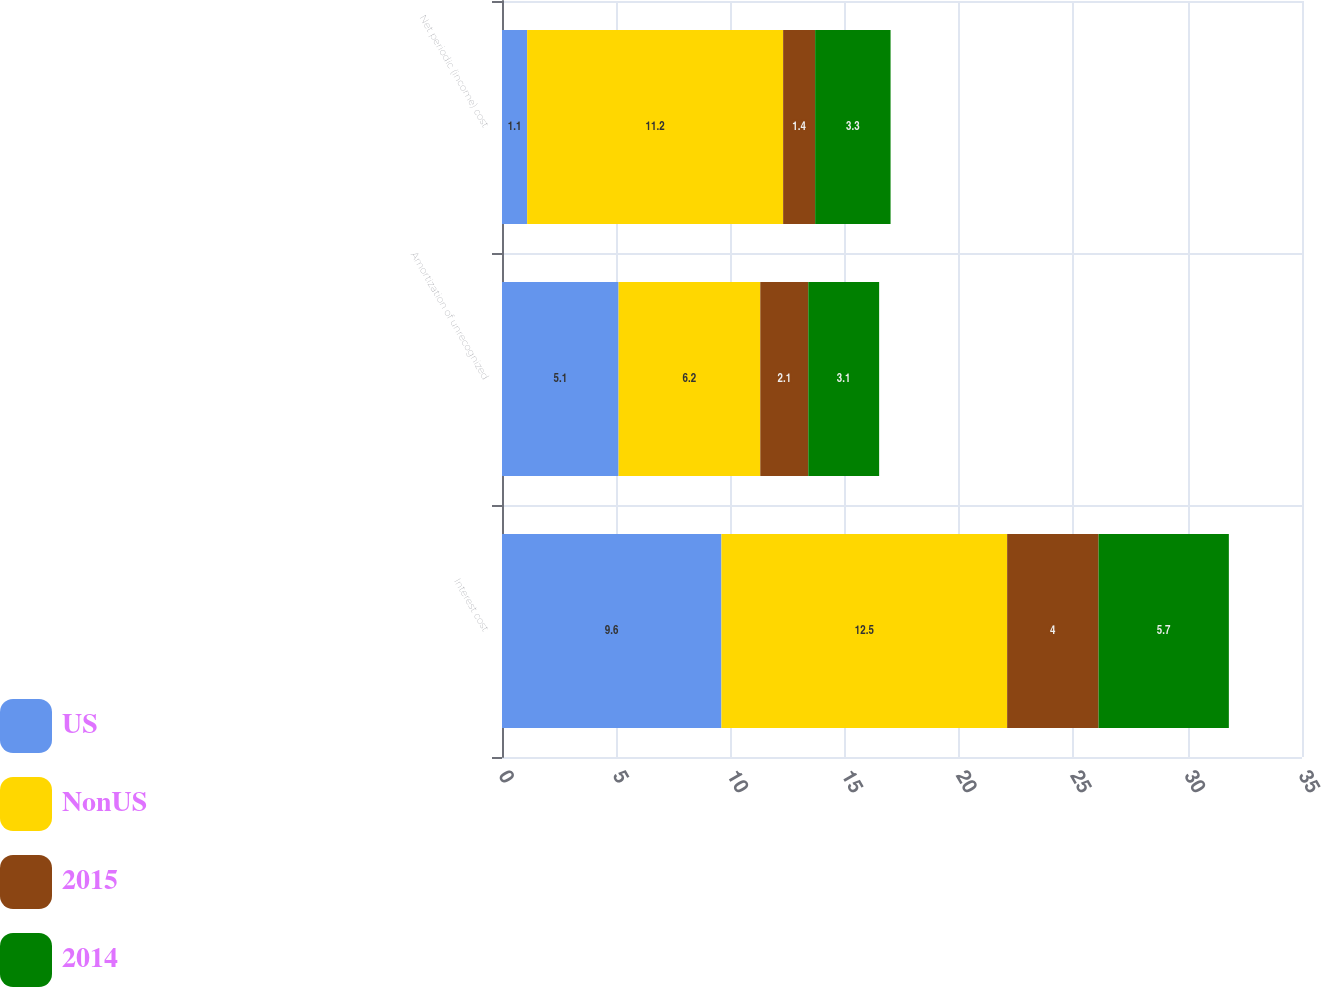<chart> <loc_0><loc_0><loc_500><loc_500><stacked_bar_chart><ecel><fcel>Interest cost<fcel>Amortization of unrecognized<fcel>Net periodic (income) cost<nl><fcel>US<fcel>9.6<fcel>5.1<fcel>1.1<nl><fcel>NonUS<fcel>12.5<fcel>6.2<fcel>11.2<nl><fcel>2015<fcel>4<fcel>2.1<fcel>1.4<nl><fcel>2014<fcel>5.7<fcel>3.1<fcel>3.3<nl></chart> 